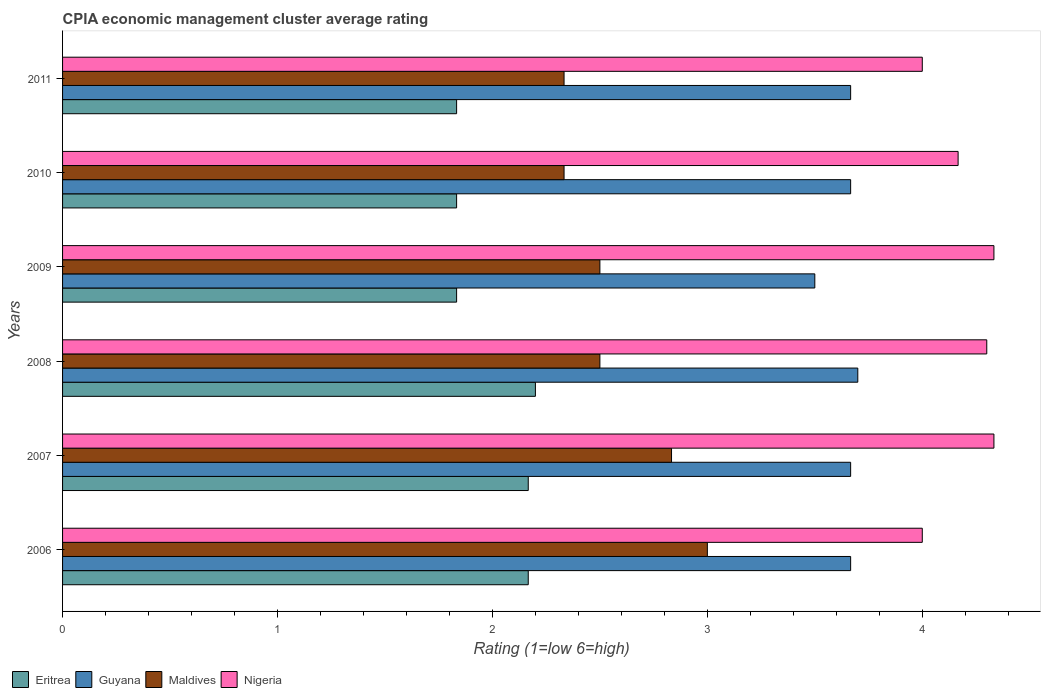How many different coloured bars are there?
Make the answer very short. 4. Are the number of bars per tick equal to the number of legend labels?
Provide a short and direct response. Yes. How many bars are there on the 3rd tick from the top?
Your response must be concise. 4. How many bars are there on the 1st tick from the bottom?
Your answer should be compact. 4. What is the CPIA rating in Guyana in 2006?
Provide a short and direct response. 3.67. Across all years, what is the minimum CPIA rating in Nigeria?
Provide a succinct answer. 4. In which year was the CPIA rating in Eritrea maximum?
Your answer should be very brief. 2008. What is the total CPIA rating in Guyana in the graph?
Your response must be concise. 21.87. What is the difference between the CPIA rating in Maldives in 2007 and that in 2011?
Provide a short and direct response. 0.5. What is the difference between the CPIA rating in Nigeria in 2009 and the CPIA rating in Guyana in 2008?
Your answer should be very brief. 0.63. What is the average CPIA rating in Maldives per year?
Make the answer very short. 2.58. In the year 2006, what is the difference between the CPIA rating in Maldives and CPIA rating in Eritrea?
Offer a very short reply. 0.83. What is the ratio of the CPIA rating in Guyana in 2008 to that in 2009?
Keep it short and to the point. 1.06. What is the difference between the highest and the second highest CPIA rating in Eritrea?
Make the answer very short. 0.03. What is the difference between the highest and the lowest CPIA rating in Eritrea?
Provide a succinct answer. 0.37. Is the sum of the CPIA rating in Maldives in 2007 and 2011 greater than the maximum CPIA rating in Eritrea across all years?
Your answer should be compact. Yes. What does the 2nd bar from the top in 2010 represents?
Your response must be concise. Maldives. What does the 2nd bar from the bottom in 2011 represents?
Make the answer very short. Guyana. Are all the bars in the graph horizontal?
Provide a succinct answer. Yes. How many years are there in the graph?
Your response must be concise. 6. What is the difference between two consecutive major ticks on the X-axis?
Give a very brief answer. 1. Are the values on the major ticks of X-axis written in scientific E-notation?
Offer a terse response. No. Does the graph contain grids?
Ensure brevity in your answer.  No. What is the title of the graph?
Provide a short and direct response. CPIA economic management cluster average rating. Does "United Arab Emirates" appear as one of the legend labels in the graph?
Make the answer very short. No. What is the Rating (1=low 6=high) in Eritrea in 2006?
Keep it short and to the point. 2.17. What is the Rating (1=low 6=high) of Guyana in 2006?
Provide a succinct answer. 3.67. What is the Rating (1=low 6=high) of Nigeria in 2006?
Make the answer very short. 4. What is the Rating (1=low 6=high) in Eritrea in 2007?
Your answer should be very brief. 2.17. What is the Rating (1=low 6=high) of Guyana in 2007?
Your response must be concise. 3.67. What is the Rating (1=low 6=high) in Maldives in 2007?
Ensure brevity in your answer.  2.83. What is the Rating (1=low 6=high) of Nigeria in 2007?
Make the answer very short. 4.33. What is the Rating (1=low 6=high) in Eritrea in 2008?
Your response must be concise. 2.2. What is the Rating (1=low 6=high) in Maldives in 2008?
Your response must be concise. 2.5. What is the Rating (1=low 6=high) in Eritrea in 2009?
Your response must be concise. 1.83. What is the Rating (1=low 6=high) in Guyana in 2009?
Your response must be concise. 3.5. What is the Rating (1=low 6=high) in Maldives in 2009?
Give a very brief answer. 2.5. What is the Rating (1=low 6=high) of Nigeria in 2009?
Your answer should be compact. 4.33. What is the Rating (1=low 6=high) in Eritrea in 2010?
Your answer should be very brief. 1.83. What is the Rating (1=low 6=high) in Guyana in 2010?
Your answer should be compact. 3.67. What is the Rating (1=low 6=high) of Maldives in 2010?
Give a very brief answer. 2.33. What is the Rating (1=low 6=high) of Nigeria in 2010?
Provide a short and direct response. 4.17. What is the Rating (1=low 6=high) of Eritrea in 2011?
Keep it short and to the point. 1.83. What is the Rating (1=low 6=high) in Guyana in 2011?
Offer a very short reply. 3.67. What is the Rating (1=low 6=high) in Maldives in 2011?
Your response must be concise. 2.33. Across all years, what is the maximum Rating (1=low 6=high) in Maldives?
Give a very brief answer. 3. Across all years, what is the maximum Rating (1=low 6=high) in Nigeria?
Your answer should be compact. 4.33. Across all years, what is the minimum Rating (1=low 6=high) of Eritrea?
Make the answer very short. 1.83. Across all years, what is the minimum Rating (1=low 6=high) of Maldives?
Offer a very short reply. 2.33. What is the total Rating (1=low 6=high) in Eritrea in the graph?
Give a very brief answer. 12.03. What is the total Rating (1=low 6=high) in Guyana in the graph?
Make the answer very short. 21.87. What is the total Rating (1=low 6=high) in Nigeria in the graph?
Ensure brevity in your answer.  25.13. What is the difference between the Rating (1=low 6=high) of Eritrea in 2006 and that in 2007?
Make the answer very short. 0. What is the difference between the Rating (1=low 6=high) in Guyana in 2006 and that in 2007?
Make the answer very short. 0. What is the difference between the Rating (1=low 6=high) in Maldives in 2006 and that in 2007?
Provide a short and direct response. 0.17. What is the difference between the Rating (1=low 6=high) in Eritrea in 2006 and that in 2008?
Your response must be concise. -0.03. What is the difference between the Rating (1=low 6=high) of Guyana in 2006 and that in 2008?
Keep it short and to the point. -0.03. What is the difference between the Rating (1=low 6=high) of Maldives in 2006 and that in 2008?
Your response must be concise. 0.5. What is the difference between the Rating (1=low 6=high) in Nigeria in 2006 and that in 2008?
Your response must be concise. -0.3. What is the difference between the Rating (1=low 6=high) of Guyana in 2006 and that in 2009?
Offer a terse response. 0.17. What is the difference between the Rating (1=low 6=high) of Maldives in 2006 and that in 2009?
Offer a terse response. 0.5. What is the difference between the Rating (1=low 6=high) of Nigeria in 2006 and that in 2009?
Keep it short and to the point. -0.33. What is the difference between the Rating (1=low 6=high) in Eritrea in 2006 and that in 2010?
Keep it short and to the point. 0.33. What is the difference between the Rating (1=low 6=high) of Eritrea in 2006 and that in 2011?
Make the answer very short. 0.33. What is the difference between the Rating (1=low 6=high) in Nigeria in 2006 and that in 2011?
Offer a terse response. 0. What is the difference between the Rating (1=low 6=high) of Eritrea in 2007 and that in 2008?
Keep it short and to the point. -0.03. What is the difference between the Rating (1=low 6=high) of Guyana in 2007 and that in 2008?
Your response must be concise. -0.03. What is the difference between the Rating (1=low 6=high) of Eritrea in 2007 and that in 2009?
Offer a very short reply. 0.33. What is the difference between the Rating (1=low 6=high) in Maldives in 2007 and that in 2009?
Keep it short and to the point. 0.33. What is the difference between the Rating (1=low 6=high) of Nigeria in 2007 and that in 2009?
Provide a succinct answer. 0. What is the difference between the Rating (1=low 6=high) in Guyana in 2007 and that in 2010?
Your answer should be compact. 0. What is the difference between the Rating (1=low 6=high) in Maldives in 2007 and that in 2010?
Your answer should be compact. 0.5. What is the difference between the Rating (1=low 6=high) in Nigeria in 2007 and that in 2010?
Your answer should be compact. 0.17. What is the difference between the Rating (1=low 6=high) in Eritrea in 2007 and that in 2011?
Your answer should be compact. 0.33. What is the difference between the Rating (1=low 6=high) of Eritrea in 2008 and that in 2009?
Offer a terse response. 0.37. What is the difference between the Rating (1=low 6=high) in Guyana in 2008 and that in 2009?
Make the answer very short. 0.2. What is the difference between the Rating (1=low 6=high) in Maldives in 2008 and that in 2009?
Offer a terse response. 0. What is the difference between the Rating (1=low 6=high) of Nigeria in 2008 and that in 2009?
Your answer should be very brief. -0.03. What is the difference between the Rating (1=low 6=high) of Eritrea in 2008 and that in 2010?
Provide a succinct answer. 0.37. What is the difference between the Rating (1=low 6=high) in Guyana in 2008 and that in 2010?
Your answer should be very brief. 0.03. What is the difference between the Rating (1=low 6=high) in Nigeria in 2008 and that in 2010?
Make the answer very short. 0.13. What is the difference between the Rating (1=low 6=high) of Eritrea in 2008 and that in 2011?
Your answer should be very brief. 0.37. What is the difference between the Rating (1=low 6=high) in Guyana in 2008 and that in 2011?
Your response must be concise. 0.03. What is the difference between the Rating (1=low 6=high) of Maldives in 2008 and that in 2011?
Provide a short and direct response. 0.17. What is the difference between the Rating (1=low 6=high) in Eritrea in 2009 and that in 2010?
Give a very brief answer. 0. What is the difference between the Rating (1=low 6=high) of Guyana in 2009 and that in 2010?
Your answer should be compact. -0.17. What is the difference between the Rating (1=low 6=high) of Nigeria in 2009 and that in 2010?
Your response must be concise. 0.17. What is the difference between the Rating (1=low 6=high) in Eritrea in 2009 and that in 2011?
Keep it short and to the point. 0. What is the difference between the Rating (1=low 6=high) of Maldives in 2009 and that in 2011?
Ensure brevity in your answer.  0.17. What is the difference between the Rating (1=low 6=high) in Nigeria in 2009 and that in 2011?
Provide a short and direct response. 0.33. What is the difference between the Rating (1=low 6=high) in Maldives in 2010 and that in 2011?
Your answer should be very brief. 0. What is the difference between the Rating (1=low 6=high) of Eritrea in 2006 and the Rating (1=low 6=high) of Guyana in 2007?
Offer a very short reply. -1.5. What is the difference between the Rating (1=low 6=high) in Eritrea in 2006 and the Rating (1=low 6=high) in Maldives in 2007?
Keep it short and to the point. -0.67. What is the difference between the Rating (1=low 6=high) in Eritrea in 2006 and the Rating (1=low 6=high) in Nigeria in 2007?
Provide a succinct answer. -2.17. What is the difference between the Rating (1=low 6=high) in Guyana in 2006 and the Rating (1=low 6=high) in Maldives in 2007?
Keep it short and to the point. 0.83. What is the difference between the Rating (1=low 6=high) in Maldives in 2006 and the Rating (1=low 6=high) in Nigeria in 2007?
Provide a short and direct response. -1.33. What is the difference between the Rating (1=low 6=high) in Eritrea in 2006 and the Rating (1=low 6=high) in Guyana in 2008?
Your response must be concise. -1.53. What is the difference between the Rating (1=low 6=high) of Eritrea in 2006 and the Rating (1=low 6=high) of Maldives in 2008?
Keep it short and to the point. -0.33. What is the difference between the Rating (1=low 6=high) in Eritrea in 2006 and the Rating (1=low 6=high) in Nigeria in 2008?
Provide a short and direct response. -2.13. What is the difference between the Rating (1=low 6=high) in Guyana in 2006 and the Rating (1=low 6=high) in Nigeria in 2008?
Ensure brevity in your answer.  -0.63. What is the difference between the Rating (1=low 6=high) in Eritrea in 2006 and the Rating (1=low 6=high) in Guyana in 2009?
Offer a very short reply. -1.33. What is the difference between the Rating (1=low 6=high) in Eritrea in 2006 and the Rating (1=low 6=high) in Nigeria in 2009?
Ensure brevity in your answer.  -2.17. What is the difference between the Rating (1=low 6=high) of Guyana in 2006 and the Rating (1=low 6=high) of Maldives in 2009?
Keep it short and to the point. 1.17. What is the difference between the Rating (1=low 6=high) in Guyana in 2006 and the Rating (1=low 6=high) in Nigeria in 2009?
Make the answer very short. -0.67. What is the difference between the Rating (1=low 6=high) in Maldives in 2006 and the Rating (1=low 6=high) in Nigeria in 2009?
Keep it short and to the point. -1.33. What is the difference between the Rating (1=low 6=high) of Eritrea in 2006 and the Rating (1=low 6=high) of Maldives in 2010?
Provide a succinct answer. -0.17. What is the difference between the Rating (1=low 6=high) in Maldives in 2006 and the Rating (1=low 6=high) in Nigeria in 2010?
Your answer should be compact. -1.17. What is the difference between the Rating (1=low 6=high) in Eritrea in 2006 and the Rating (1=low 6=high) in Guyana in 2011?
Ensure brevity in your answer.  -1.5. What is the difference between the Rating (1=low 6=high) of Eritrea in 2006 and the Rating (1=low 6=high) of Nigeria in 2011?
Ensure brevity in your answer.  -1.83. What is the difference between the Rating (1=low 6=high) in Guyana in 2006 and the Rating (1=low 6=high) in Nigeria in 2011?
Make the answer very short. -0.33. What is the difference between the Rating (1=low 6=high) of Eritrea in 2007 and the Rating (1=low 6=high) of Guyana in 2008?
Your answer should be very brief. -1.53. What is the difference between the Rating (1=low 6=high) of Eritrea in 2007 and the Rating (1=low 6=high) of Nigeria in 2008?
Make the answer very short. -2.13. What is the difference between the Rating (1=low 6=high) of Guyana in 2007 and the Rating (1=low 6=high) of Nigeria in 2008?
Provide a short and direct response. -0.63. What is the difference between the Rating (1=low 6=high) of Maldives in 2007 and the Rating (1=low 6=high) of Nigeria in 2008?
Offer a very short reply. -1.47. What is the difference between the Rating (1=low 6=high) of Eritrea in 2007 and the Rating (1=low 6=high) of Guyana in 2009?
Offer a very short reply. -1.33. What is the difference between the Rating (1=low 6=high) of Eritrea in 2007 and the Rating (1=low 6=high) of Maldives in 2009?
Give a very brief answer. -0.33. What is the difference between the Rating (1=low 6=high) in Eritrea in 2007 and the Rating (1=low 6=high) in Nigeria in 2009?
Your answer should be compact. -2.17. What is the difference between the Rating (1=low 6=high) of Guyana in 2007 and the Rating (1=low 6=high) of Maldives in 2009?
Your answer should be compact. 1.17. What is the difference between the Rating (1=low 6=high) of Guyana in 2007 and the Rating (1=low 6=high) of Nigeria in 2009?
Offer a very short reply. -0.67. What is the difference between the Rating (1=low 6=high) of Guyana in 2007 and the Rating (1=low 6=high) of Maldives in 2010?
Offer a very short reply. 1.33. What is the difference between the Rating (1=low 6=high) of Maldives in 2007 and the Rating (1=low 6=high) of Nigeria in 2010?
Provide a short and direct response. -1.33. What is the difference between the Rating (1=low 6=high) in Eritrea in 2007 and the Rating (1=low 6=high) in Maldives in 2011?
Offer a terse response. -0.17. What is the difference between the Rating (1=low 6=high) of Eritrea in 2007 and the Rating (1=low 6=high) of Nigeria in 2011?
Your response must be concise. -1.83. What is the difference between the Rating (1=low 6=high) in Maldives in 2007 and the Rating (1=low 6=high) in Nigeria in 2011?
Your answer should be compact. -1.17. What is the difference between the Rating (1=low 6=high) of Eritrea in 2008 and the Rating (1=low 6=high) of Nigeria in 2009?
Provide a succinct answer. -2.13. What is the difference between the Rating (1=low 6=high) of Guyana in 2008 and the Rating (1=low 6=high) of Nigeria in 2009?
Your answer should be very brief. -0.63. What is the difference between the Rating (1=low 6=high) of Maldives in 2008 and the Rating (1=low 6=high) of Nigeria in 2009?
Give a very brief answer. -1.83. What is the difference between the Rating (1=low 6=high) in Eritrea in 2008 and the Rating (1=low 6=high) in Guyana in 2010?
Keep it short and to the point. -1.47. What is the difference between the Rating (1=low 6=high) of Eritrea in 2008 and the Rating (1=low 6=high) of Maldives in 2010?
Your response must be concise. -0.13. What is the difference between the Rating (1=low 6=high) of Eritrea in 2008 and the Rating (1=low 6=high) of Nigeria in 2010?
Offer a terse response. -1.97. What is the difference between the Rating (1=low 6=high) of Guyana in 2008 and the Rating (1=low 6=high) of Maldives in 2010?
Give a very brief answer. 1.37. What is the difference between the Rating (1=low 6=high) of Guyana in 2008 and the Rating (1=low 6=high) of Nigeria in 2010?
Your answer should be very brief. -0.47. What is the difference between the Rating (1=low 6=high) of Maldives in 2008 and the Rating (1=low 6=high) of Nigeria in 2010?
Offer a very short reply. -1.67. What is the difference between the Rating (1=low 6=high) in Eritrea in 2008 and the Rating (1=low 6=high) in Guyana in 2011?
Offer a terse response. -1.47. What is the difference between the Rating (1=low 6=high) of Eritrea in 2008 and the Rating (1=low 6=high) of Maldives in 2011?
Provide a short and direct response. -0.13. What is the difference between the Rating (1=low 6=high) in Eritrea in 2008 and the Rating (1=low 6=high) in Nigeria in 2011?
Keep it short and to the point. -1.8. What is the difference between the Rating (1=low 6=high) in Guyana in 2008 and the Rating (1=low 6=high) in Maldives in 2011?
Offer a terse response. 1.37. What is the difference between the Rating (1=low 6=high) in Eritrea in 2009 and the Rating (1=low 6=high) in Guyana in 2010?
Your response must be concise. -1.83. What is the difference between the Rating (1=low 6=high) of Eritrea in 2009 and the Rating (1=low 6=high) of Maldives in 2010?
Your response must be concise. -0.5. What is the difference between the Rating (1=low 6=high) in Eritrea in 2009 and the Rating (1=low 6=high) in Nigeria in 2010?
Keep it short and to the point. -2.33. What is the difference between the Rating (1=low 6=high) in Guyana in 2009 and the Rating (1=low 6=high) in Nigeria in 2010?
Provide a short and direct response. -0.67. What is the difference between the Rating (1=low 6=high) in Maldives in 2009 and the Rating (1=low 6=high) in Nigeria in 2010?
Keep it short and to the point. -1.67. What is the difference between the Rating (1=low 6=high) of Eritrea in 2009 and the Rating (1=low 6=high) of Guyana in 2011?
Provide a succinct answer. -1.83. What is the difference between the Rating (1=low 6=high) in Eritrea in 2009 and the Rating (1=low 6=high) in Maldives in 2011?
Ensure brevity in your answer.  -0.5. What is the difference between the Rating (1=low 6=high) in Eritrea in 2009 and the Rating (1=low 6=high) in Nigeria in 2011?
Make the answer very short. -2.17. What is the difference between the Rating (1=low 6=high) in Guyana in 2009 and the Rating (1=low 6=high) in Maldives in 2011?
Offer a terse response. 1.17. What is the difference between the Rating (1=low 6=high) of Maldives in 2009 and the Rating (1=low 6=high) of Nigeria in 2011?
Your response must be concise. -1.5. What is the difference between the Rating (1=low 6=high) in Eritrea in 2010 and the Rating (1=low 6=high) in Guyana in 2011?
Offer a very short reply. -1.83. What is the difference between the Rating (1=low 6=high) of Eritrea in 2010 and the Rating (1=low 6=high) of Nigeria in 2011?
Give a very brief answer. -2.17. What is the difference between the Rating (1=low 6=high) in Guyana in 2010 and the Rating (1=low 6=high) in Maldives in 2011?
Keep it short and to the point. 1.33. What is the difference between the Rating (1=low 6=high) of Maldives in 2010 and the Rating (1=low 6=high) of Nigeria in 2011?
Your response must be concise. -1.67. What is the average Rating (1=low 6=high) of Eritrea per year?
Offer a very short reply. 2.01. What is the average Rating (1=low 6=high) in Guyana per year?
Your answer should be compact. 3.64. What is the average Rating (1=low 6=high) of Maldives per year?
Offer a terse response. 2.58. What is the average Rating (1=low 6=high) of Nigeria per year?
Give a very brief answer. 4.19. In the year 2006, what is the difference between the Rating (1=low 6=high) of Eritrea and Rating (1=low 6=high) of Nigeria?
Keep it short and to the point. -1.83. In the year 2006, what is the difference between the Rating (1=low 6=high) in Guyana and Rating (1=low 6=high) in Maldives?
Make the answer very short. 0.67. In the year 2007, what is the difference between the Rating (1=low 6=high) of Eritrea and Rating (1=low 6=high) of Guyana?
Your answer should be very brief. -1.5. In the year 2007, what is the difference between the Rating (1=low 6=high) of Eritrea and Rating (1=low 6=high) of Nigeria?
Give a very brief answer. -2.17. In the year 2007, what is the difference between the Rating (1=low 6=high) in Guyana and Rating (1=low 6=high) in Nigeria?
Ensure brevity in your answer.  -0.67. In the year 2007, what is the difference between the Rating (1=low 6=high) in Maldives and Rating (1=low 6=high) in Nigeria?
Give a very brief answer. -1.5. In the year 2008, what is the difference between the Rating (1=low 6=high) of Eritrea and Rating (1=low 6=high) of Maldives?
Provide a succinct answer. -0.3. In the year 2008, what is the difference between the Rating (1=low 6=high) of Guyana and Rating (1=low 6=high) of Nigeria?
Your response must be concise. -0.6. In the year 2009, what is the difference between the Rating (1=low 6=high) of Eritrea and Rating (1=low 6=high) of Guyana?
Your answer should be very brief. -1.67. In the year 2009, what is the difference between the Rating (1=low 6=high) in Eritrea and Rating (1=low 6=high) in Nigeria?
Make the answer very short. -2.5. In the year 2009, what is the difference between the Rating (1=low 6=high) of Maldives and Rating (1=low 6=high) of Nigeria?
Ensure brevity in your answer.  -1.83. In the year 2010, what is the difference between the Rating (1=low 6=high) of Eritrea and Rating (1=low 6=high) of Guyana?
Keep it short and to the point. -1.83. In the year 2010, what is the difference between the Rating (1=low 6=high) in Eritrea and Rating (1=low 6=high) in Nigeria?
Your response must be concise. -2.33. In the year 2010, what is the difference between the Rating (1=low 6=high) of Guyana and Rating (1=low 6=high) of Maldives?
Give a very brief answer. 1.33. In the year 2010, what is the difference between the Rating (1=low 6=high) in Guyana and Rating (1=low 6=high) in Nigeria?
Your response must be concise. -0.5. In the year 2010, what is the difference between the Rating (1=low 6=high) in Maldives and Rating (1=low 6=high) in Nigeria?
Ensure brevity in your answer.  -1.83. In the year 2011, what is the difference between the Rating (1=low 6=high) of Eritrea and Rating (1=low 6=high) of Guyana?
Keep it short and to the point. -1.83. In the year 2011, what is the difference between the Rating (1=low 6=high) of Eritrea and Rating (1=low 6=high) of Nigeria?
Ensure brevity in your answer.  -2.17. In the year 2011, what is the difference between the Rating (1=low 6=high) of Guyana and Rating (1=low 6=high) of Maldives?
Keep it short and to the point. 1.33. In the year 2011, what is the difference between the Rating (1=low 6=high) in Guyana and Rating (1=low 6=high) in Nigeria?
Provide a succinct answer. -0.33. In the year 2011, what is the difference between the Rating (1=low 6=high) of Maldives and Rating (1=low 6=high) of Nigeria?
Provide a succinct answer. -1.67. What is the ratio of the Rating (1=low 6=high) of Maldives in 2006 to that in 2007?
Make the answer very short. 1.06. What is the ratio of the Rating (1=low 6=high) in Guyana in 2006 to that in 2008?
Your response must be concise. 0.99. What is the ratio of the Rating (1=low 6=high) in Maldives in 2006 to that in 2008?
Provide a short and direct response. 1.2. What is the ratio of the Rating (1=low 6=high) in Nigeria in 2006 to that in 2008?
Offer a terse response. 0.93. What is the ratio of the Rating (1=low 6=high) in Eritrea in 2006 to that in 2009?
Provide a succinct answer. 1.18. What is the ratio of the Rating (1=low 6=high) in Guyana in 2006 to that in 2009?
Make the answer very short. 1.05. What is the ratio of the Rating (1=low 6=high) of Maldives in 2006 to that in 2009?
Offer a terse response. 1.2. What is the ratio of the Rating (1=low 6=high) of Nigeria in 2006 to that in 2009?
Your answer should be very brief. 0.92. What is the ratio of the Rating (1=low 6=high) in Eritrea in 2006 to that in 2010?
Give a very brief answer. 1.18. What is the ratio of the Rating (1=low 6=high) of Guyana in 2006 to that in 2010?
Provide a short and direct response. 1. What is the ratio of the Rating (1=low 6=high) of Eritrea in 2006 to that in 2011?
Keep it short and to the point. 1.18. What is the ratio of the Rating (1=low 6=high) of Guyana in 2006 to that in 2011?
Your answer should be compact. 1. What is the ratio of the Rating (1=low 6=high) of Maldives in 2006 to that in 2011?
Ensure brevity in your answer.  1.29. What is the ratio of the Rating (1=low 6=high) in Eritrea in 2007 to that in 2008?
Provide a short and direct response. 0.98. What is the ratio of the Rating (1=low 6=high) of Maldives in 2007 to that in 2008?
Give a very brief answer. 1.13. What is the ratio of the Rating (1=low 6=high) in Nigeria in 2007 to that in 2008?
Provide a short and direct response. 1.01. What is the ratio of the Rating (1=low 6=high) in Eritrea in 2007 to that in 2009?
Keep it short and to the point. 1.18. What is the ratio of the Rating (1=low 6=high) in Guyana in 2007 to that in 2009?
Your answer should be very brief. 1.05. What is the ratio of the Rating (1=low 6=high) of Maldives in 2007 to that in 2009?
Keep it short and to the point. 1.13. What is the ratio of the Rating (1=low 6=high) in Nigeria in 2007 to that in 2009?
Your response must be concise. 1. What is the ratio of the Rating (1=low 6=high) in Eritrea in 2007 to that in 2010?
Offer a terse response. 1.18. What is the ratio of the Rating (1=low 6=high) of Maldives in 2007 to that in 2010?
Offer a terse response. 1.21. What is the ratio of the Rating (1=low 6=high) of Nigeria in 2007 to that in 2010?
Provide a short and direct response. 1.04. What is the ratio of the Rating (1=low 6=high) of Eritrea in 2007 to that in 2011?
Your answer should be very brief. 1.18. What is the ratio of the Rating (1=low 6=high) of Guyana in 2007 to that in 2011?
Your answer should be compact. 1. What is the ratio of the Rating (1=low 6=high) in Maldives in 2007 to that in 2011?
Make the answer very short. 1.21. What is the ratio of the Rating (1=low 6=high) in Nigeria in 2007 to that in 2011?
Ensure brevity in your answer.  1.08. What is the ratio of the Rating (1=low 6=high) in Guyana in 2008 to that in 2009?
Your response must be concise. 1.06. What is the ratio of the Rating (1=low 6=high) in Maldives in 2008 to that in 2009?
Ensure brevity in your answer.  1. What is the ratio of the Rating (1=low 6=high) in Nigeria in 2008 to that in 2009?
Provide a succinct answer. 0.99. What is the ratio of the Rating (1=low 6=high) in Guyana in 2008 to that in 2010?
Offer a terse response. 1.01. What is the ratio of the Rating (1=low 6=high) in Maldives in 2008 to that in 2010?
Provide a succinct answer. 1.07. What is the ratio of the Rating (1=low 6=high) of Nigeria in 2008 to that in 2010?
Provide a short and direct response. 1.03. What is the ratio of the Rating (1=low 6=high) in Eritrea in 2008 to that in 2011?
Your answer should be very brief. 1.2. What is the ratio of the Rating (1=low 6=high) in Guyana in 2008 to that in 2011?
Keep it short and to the point. 1.01. What is the ratio of the Rating (1=low 6=high) in Maldives in 2008 to that in 2011?
Provide a succinct answer. 1.07. What is the ratio of the Rating (1=low 6=high) of Nigeria in 2008 to that in 2011?
Keep it short and to the point. 1.07. What is the ratio of the Rating (1=low 6=high) of Guyana in 2009 to that in 2010?
Ensure brevity in your answer.  0.95. What is the ratio of the Rating (1=low 6=high) of Maldives in 2009 to that in 2010?
Provide a succinct answer. 1.07. What is the ratio of the Rating (1=low 6=high) in Nigeria in 2009 to that in 2010?
Offer a very short reply. 1.04. What is the ratio of the Rating (1=low 6=high) in Guyana in 2009 to that in 2011?
Ensure brevity in your answer.  0.95. What is the ratio of the Rating (1=low 6=high) in Maldives in 2009 to that in 2011?
Your response must be concise. 1.07. What is the ratio of the Rating (1=low 6=high) of Guyana in 2010 to that in 2011?
Provide a succinct answer. 1. What is the ratio of the Rating (1=low 6=high) in Maldives in 2010 to that in 2011?
Your answer should be compact. 1. What is the ratio of the Rating (1=low 6=high) in Nigeria in 2010 to that in 2011?
Ensure brevity in your answer.  1.04. What is the difference between the highest and the second highest Rating (1=low 6=high) of Eritrea?
Give a very brief answer. 0.03. What is the difference between the highest and the second highest Rating (1=low 6=high) in Guyana?
Your answer should be compact. 0.03. What is the difference between the highest and the second highest Rating (1=low 6=high) in Maldives?
Offer a terse response. 0.17. What is the difference between the highest and the second highest Rating (1=low 6=high) in Nigeria?
Give a very brief answer. 0. What is the difference between the highest and the lowest Rating (1=low 6=high) of Eritrea?
Provide a succinct answer. 0.37. What is the difference between the highest and the lowest Rating (1=low 6=high) of Guyana?
Ensure brevity in your answer.  0.2. What is the difference between the highest and the lowest Rating (1=low 6=high) in Maldives?
Provide a short and direct response. 0.67. 